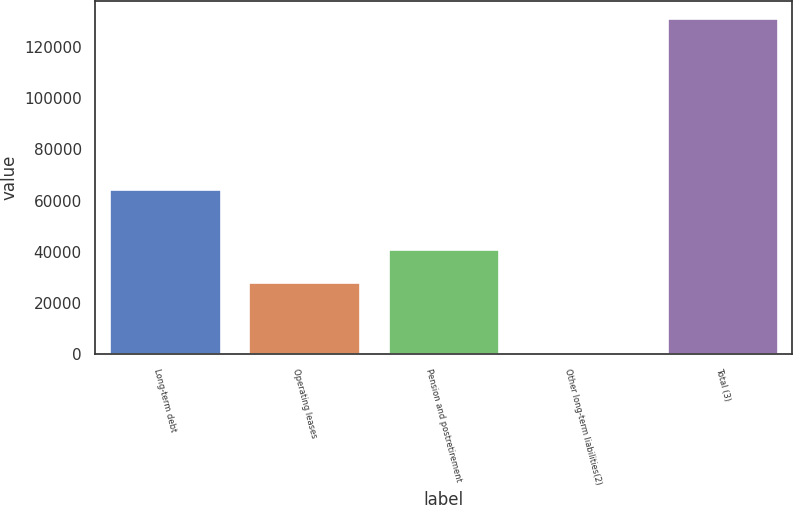Convert chart to OTSL. <chart><loc_0><loc_0><loc_500><loc_500><bar_chart><fcel>Long-term debt<fcel>Operating leases<fcel>Pension and postretirement<fcel>Other long-term liabilities(2)<fcel>Total (3)<nl><fcel>64623<fcel>28192<fcel>41266.8<fcel>678<fcel>131426<nl></chart> 